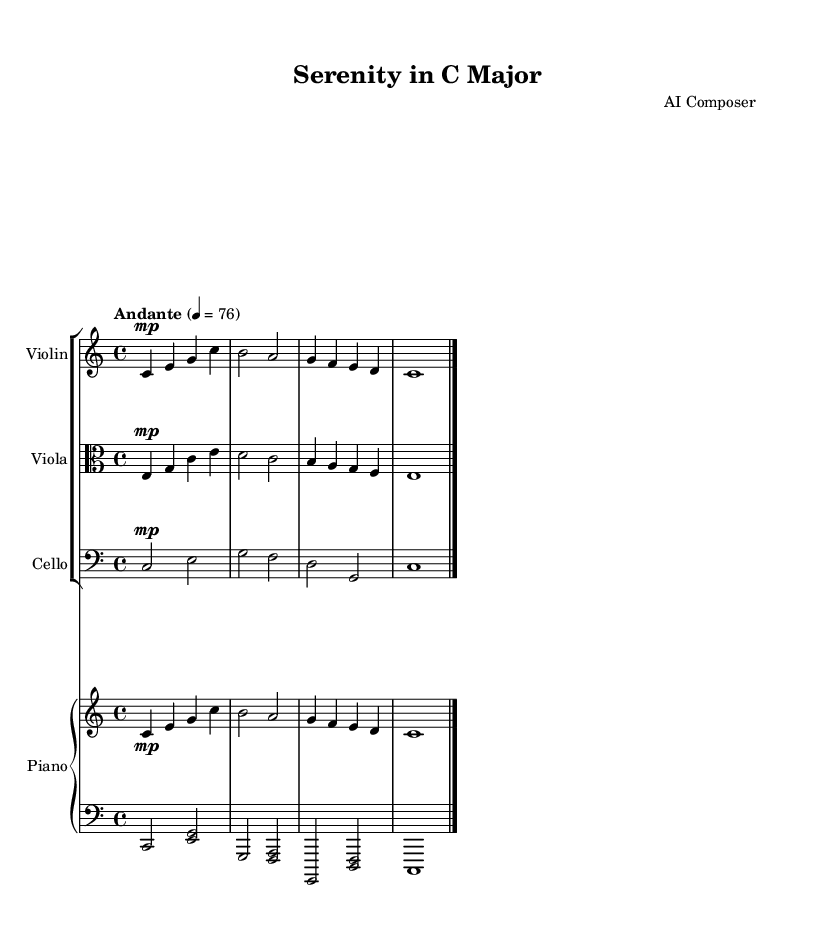What is the key signature of this music? The key signature is indicated at the beginning of the score, showing no sharps or flats. This means that the scale is based on C major.
Answer: C major What is the time signature of this piece? The time signature is shown at the beginning of the score with a "4/4" indicator, which means there are four beats in each measure.
Answer: 4/4 What is the tempo marking for this piece? The tempo marking is specified in Italian, indicating how fast the piece should be played. Here it is marked as "Andante," which translates to a moderate speed.
Answer: Andante How many measures are there in this excerpt? To determine the number of measures, count the number of vertical lines (bar lines) in the score. Each bar line represents the end of a measure. There are four measures before the final bar line.
Answer: 4 What instruments are featured in this chamber music? The instruments are listed in the score with their corresponding names. The score contains a Violin, Viola, Cello, and Piano.
Answer: Violin, Viola, Cello, Piano In which clef is the viola written? The clef used for the viola is indicated as "alto" clef, which is typically used for this instrument. This is visible in the staff formatting for the viola.
Answer: Alto clef What is the dynamic marking for the strings in this piece? The dynamic markings for the strings indicate a "mezzo-piano" level of volume, represented by "mp." This is noted at the beginning of the violin and viola parts, suggesting a soft playing level.
Answer: Mezzo-piano 